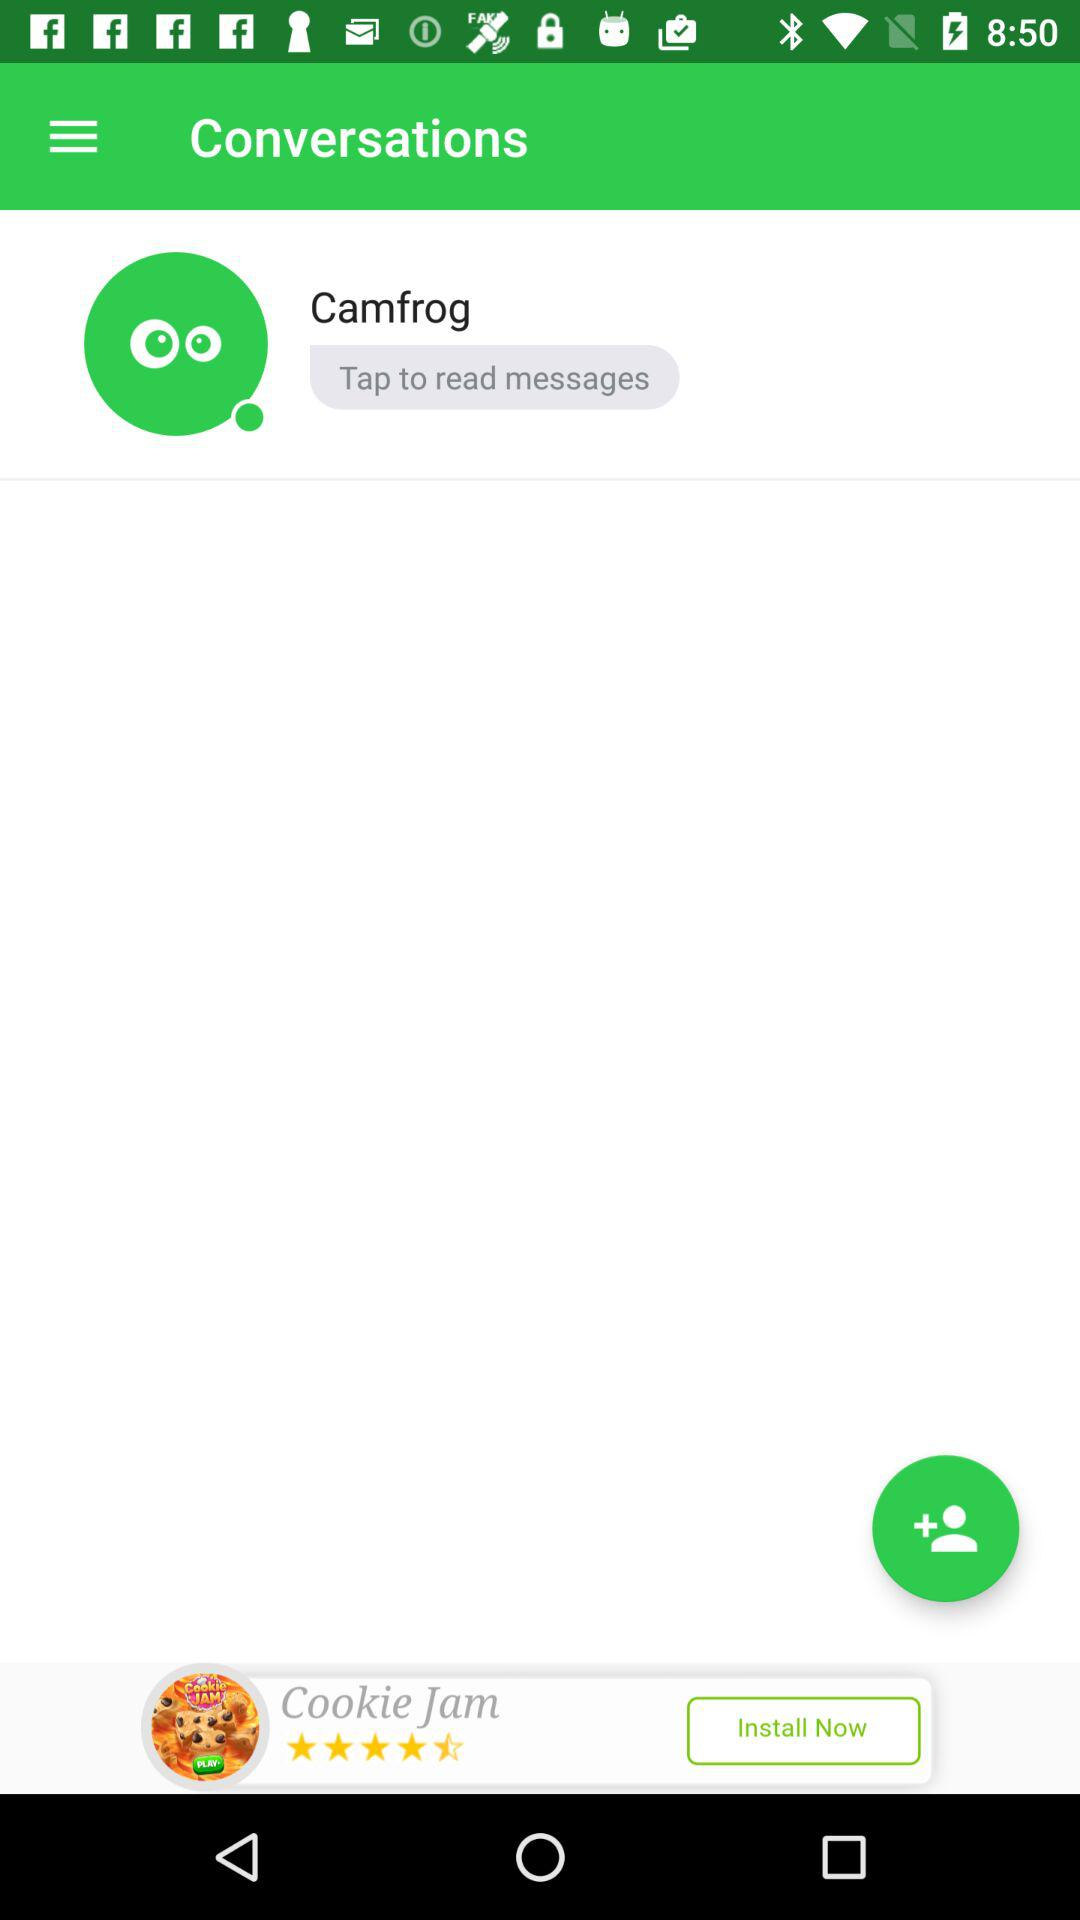What is the profile name? The profile name is Camfrog. 